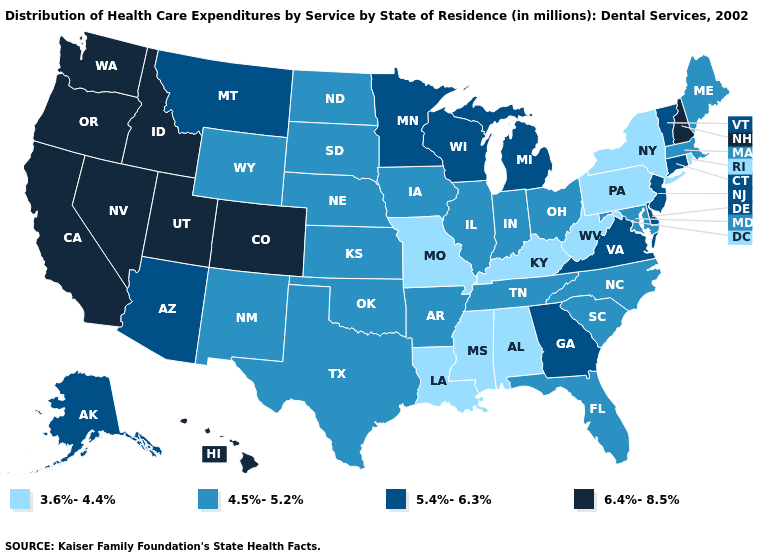Does Hawaii have a lower value than Kansas?
Concise answer only. No. What is the highest value in the MidWest ?
Write a very short answer. 5.4%-6.3%. What is the value of Arkansas?
Keep it brief. 4.5%-5.2%. Name the states that have a value in the range 4.5%-5.2%?
Write a very short answer. Arkansas, Florida, Illinois, Indiana, Iowa, Kansas, Maine, Maryland, Massachusetts, Nebraska, New Mexico, North Carolina, North Dakota, Ohio, Oklahoma, South Carolina, South Dakota, Tennessee, Texas, Wyoming. Among the states that border Florida , which have the highest value?
Short answer required. Georgia. What is the lowest value in states that border Nebraska?
Short answer required. 3.6%-4.4%. Does Mississippi have the lowest value in the USA?
Write a very short answer. Yes. What is the lowest value in the MidWest?
Short answer required. 3.6%-4.4%. What is the highest value in the USA?
Short answer required. 6.4%-8.5%. Name the states that have a value in the range 6.4%-8.5%?
Answer briefly. California, Colorado, Hawaii, Idaho, Nevada, New Hampshire, Oregon, Utah, Washington. Name the states that have a value in the range 5.4%-6.3%?
Keep it brief. Alaska, Arizona, Connecticut, Delaware, Georgia, Michigan, Minnesota, Montana, New Jersey, Vermont, Virginia, Wisconsin. Among the states that border Nevada , which have the lowest value?
Concise answer only. Arizona. Does Massachusetts have the same value as Maine?
Concise answer only. Yes. Name the states that have a value in the range 6.4%-8.5%?
Keep it brief. California, Colorado, Hawaii, Idaho, Nevada, New Hampshire, Oregon, Utah, Washington. Name the states that have a value in the range 3.6%-4.4%?
Give a very brief answer. Alabama, Kentucky, Louisiana, Mississippi, Missouri, New York, Pennsylvania, Rhode Island, West Virginia. 